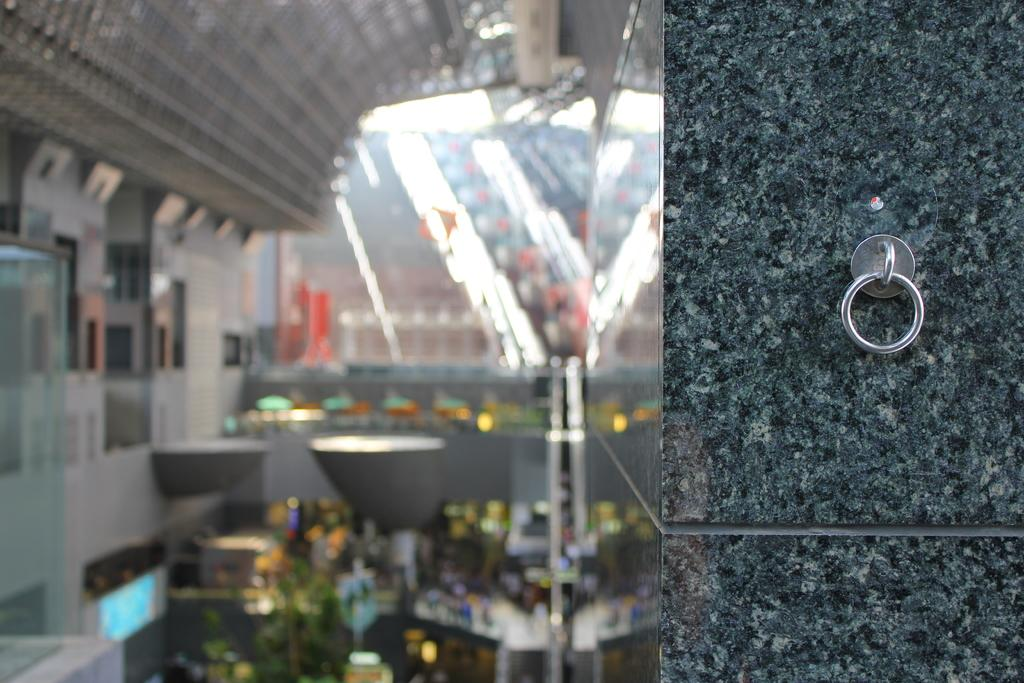What is located on the right side of the picture? There is an object on the right side of the picture. Where is the object positioned in the image? The object is on the wall. What can be observed about the left side of the picture? The left side of the picture is blurred. Despite the blurriness, are there any objects visible on the left side of the picture? Yes, there are objects visible on the left side of the picture. What type of calculator is being used by the porter in the image? There is no porter or calculator present in the image. What type of hall is depicted in the image? The image does not depict a hall; it only shows an object on the wall and some blurred objects on the left side. 